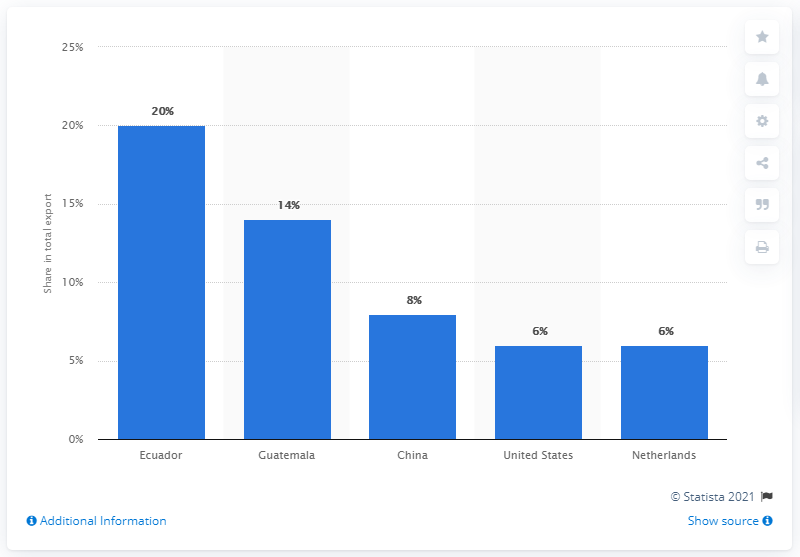Identify some key points in this picture. In 2019, Panama's most important export partner was Ecuador. In 2019, Ecuador accounted for approximately 19.3% of Panama's total exports. 